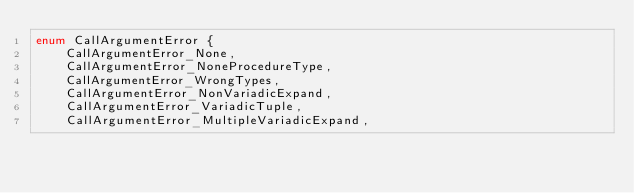<code> <loc_0><loc_0><loc_500><loc_500><_C++_>enum CallArgumentError {
	CallArgumentError_None,
	CallArgumentError_NoneProcedureType,
	CallArgumentError_WrongTypes,
	CallArgumentError_NonVariadicExpand,
	CallArgumentError_VariadicTuple,
	CallArgumentError_MultipleVariadicExpand,</code> 